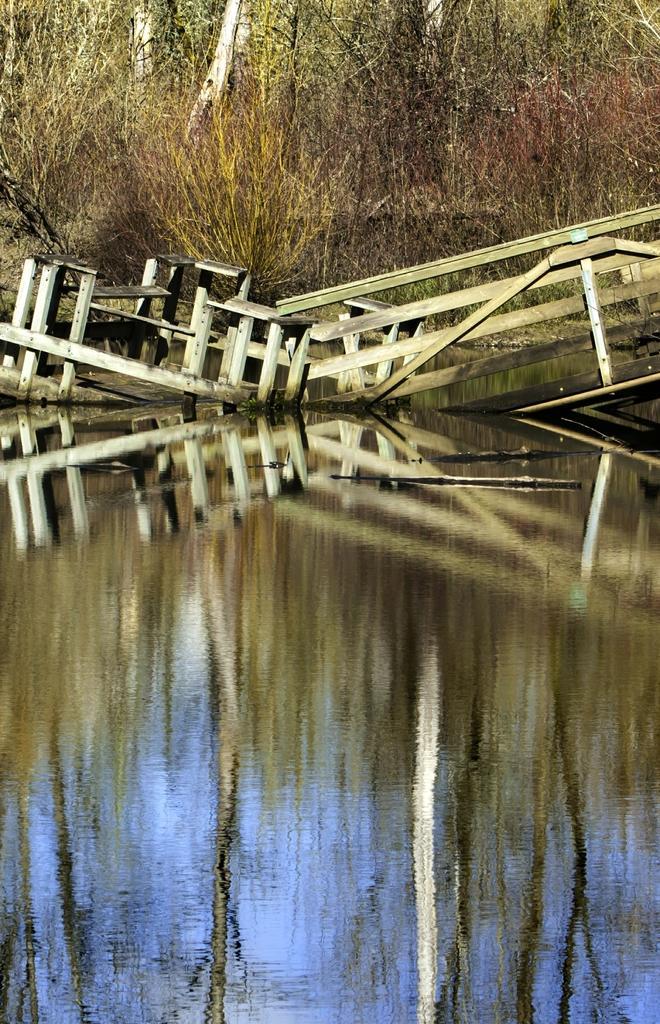Can you describe this image briefly? In this picture we can observe a wooden railing in the water. We can observe some dried plants. In the background there are trees. 